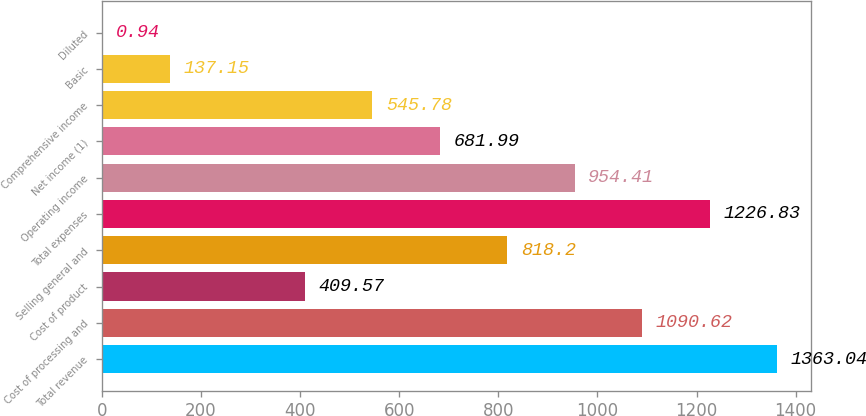Convert chart to OTSL. <chart><loc_0><loc_0><loc_500><loc_500><bar_chart><fcel>Total revenue<fcel>Cost of processing and<fcel>Cost of product<fcel>Selling general and<fcel>Total expenses<fcel>Operating income<fcel>Net income (1)<fcel>Comprehensive income<fcel>Basic<fcel>Diluted<nl><fcel>1363.04<fcel>1090.62<fcel>409.57<fcel>818.2<fcel>1226.83<fcel>954.41<fcel>681.99<fcel>545.78<fcel>137.15<fcel>0.94<nl></chart> 